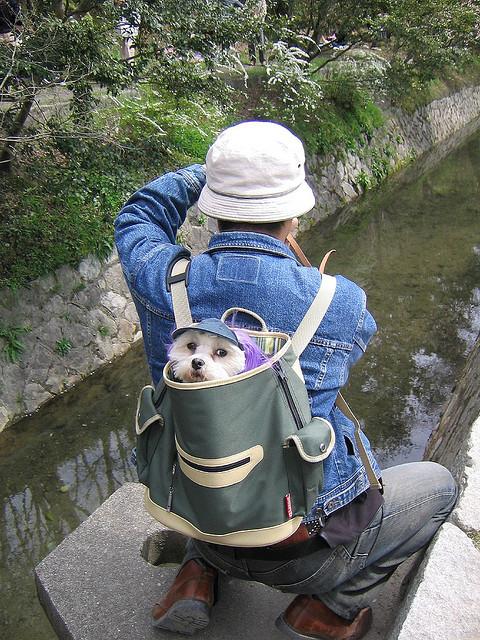What is this for?
Give a very brief answer. Carrying dog. Is the dog wearing a hat for sun protection?
Give a very brief answer. Yes. What is in the man's backpack?
Answer briefly. Dog. What breed is the dog?
Keep it brief. Poodle. 